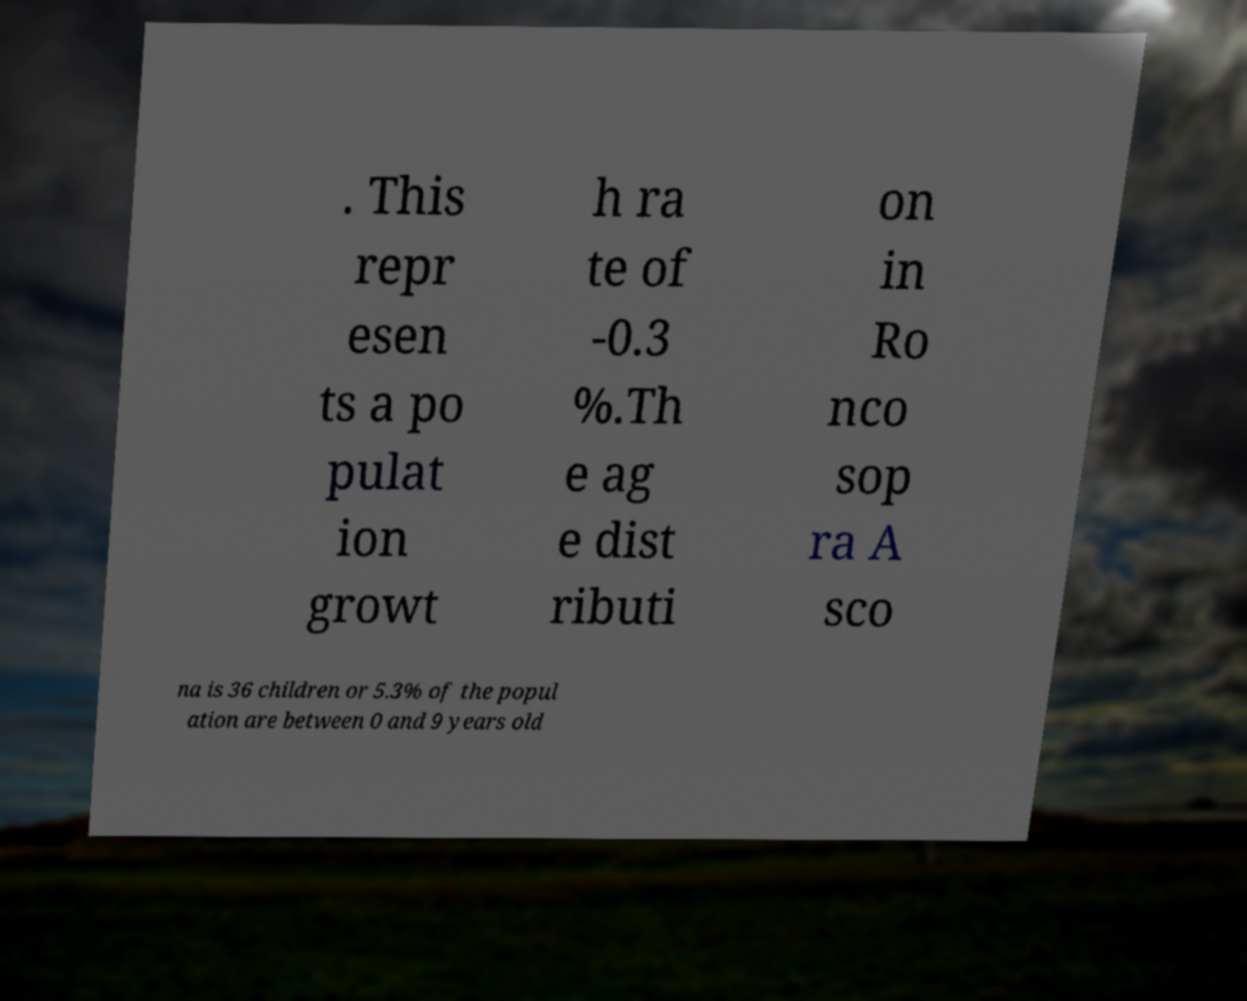Could you assist in decoding the text presented in this image and type it out clearly? . This repr esen ts a po pulat ion growt h ra te of -0.3 %.Th e ag e dist ributi on in Ro nco sop ra A sco na is 36 children or 5.3% of the popul ation are between 0 and 9 years old 